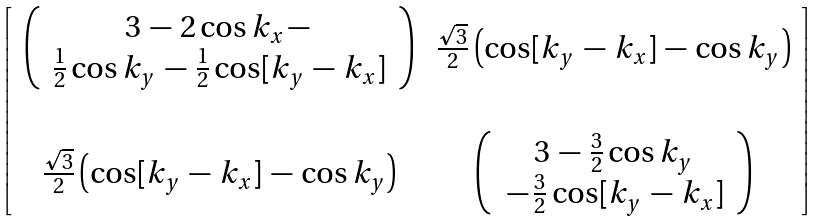<formula> <loc_0><loc_0><loc_500><loc_500>\left [ \, \begin{array} { c c } \left ( \, \begin{array} { c } 3 \, - \, 2 \cos k _ { x } \, - \, \\ \frac { 1 } { 2 } \cos k _ { y } \, - \, \frac { 1 } { 2 } \cos [ k _ { y } \, - \, k _ { x } ] \end{array} \, \right ) \, & \frac { \sqrt { 3 } } { 2 } \left ( \cos [ k _ { y } \, - \, k _ { x } ] \, - \, \cos k _ { y } \right ) \\ \\ \frac { \sqrt { 3 } } { 2 } \left ( \cos [ k _ { y } \, - \, k _ { x } ] \, - \, \cos k _ { y } \right ) \, & \left ( \, \begin{array} { c } 3 \, - \, \frac { 3 } { 2 } \cos k _ { y } \\ \, - \, \frac { 3 } { 2 } \cos [ k _ { y } \, - \, k _ { x } ] \end{array} \, \right ) \end{array} \, \right ]</formula> 